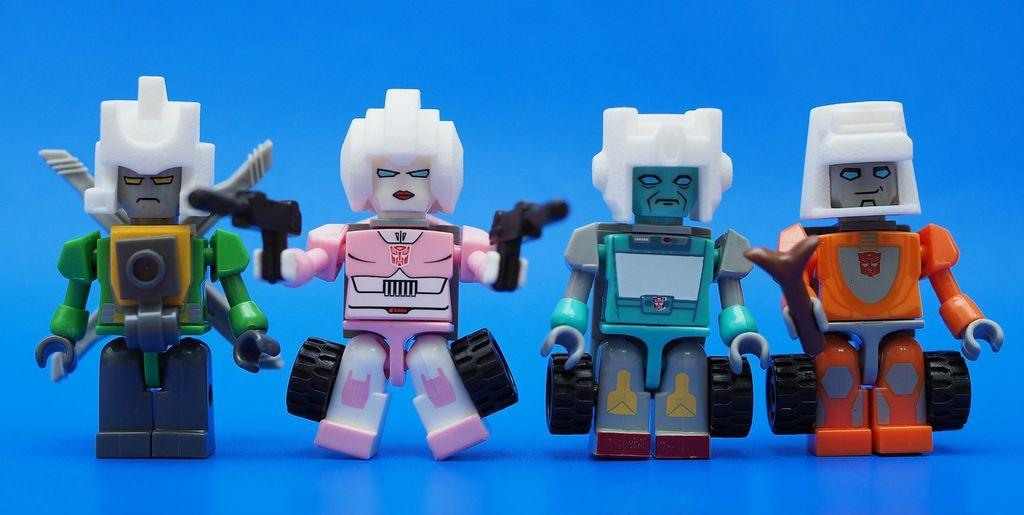How many robot toys are in the image? There are four robot toys in the image. What is the color of the surface on which the robot toys are placed? The robot toys are on a blue surface. What type of insurance policy is required for the robot toys in the image? There is no mention of insurance in the image, and the robot toys are likely toys and not subject to insurance policies. 